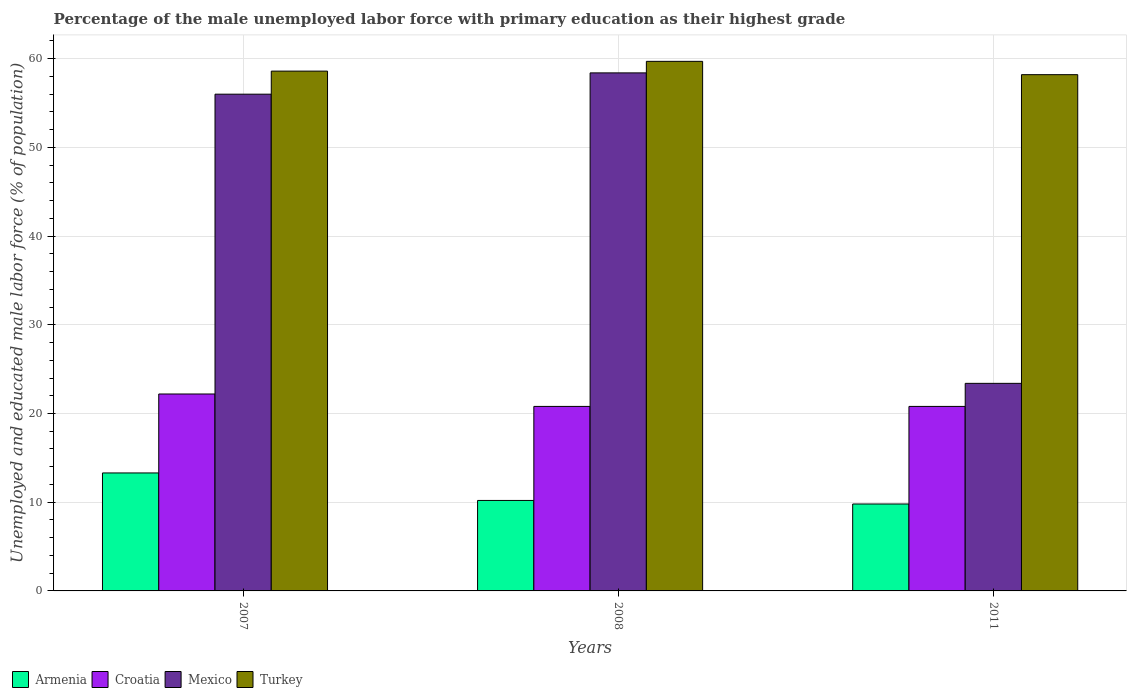How many different coloured bars are there?
Provide a succinct answer. 4. Are the number of bars per tick equal to the number of legend labels?
Give a very brief answer. Yes. Are the number of bars on each tick of the X-axis equal?
Your answer should be very brief. Yes. How many bars are there on the 2nd tick from the left?
Your answer should be very brief. 4. How many bars are there on the 2nd tick from the right?
Offer a very short reply. 4. What is the label of the 3rd group of bars from the left?
Offer a very short reply. 2011. What is the percentage of the unemployed male labor force with primary education in Turkey in 2011?
Your answer should be compact. 58.2. Across all years, what is the maximum percentage of the unemployed male labor force with primary education in Croatia?
Your response must be concise. 22.2. Across all years, what is the minimum percentage of the unemployed male labor force with primary education in Turkey?
Your answer should be very brief. 58.2. What is the total percentage of the unemployed male labor force with primary education in Turkey in the graph?
Offer a very short reply. 176.5. What is the difference between the percentage of the unemployed male labor force with primary education in Mexico in 2007 and that in 2011?
Offer a terse response. 32.6. What is the difference between the percentage of the unemployed male labor force with primary education in Mexico in 2008 and the percentage of the unemployed male labor force with primary education in Turkey in 2011?
Your answer should be compact. 0.2. What is the average percentage of the unemployed male labor force with primary education in Mexico per year?
Offer a terse response. 45.93. In the year 2008, what is the difference between the percentage of the unemployed male labor force with primary education in Turkey and percentage of the unemployed male labor force with primary education in Mexico?
Offer a terse response. 1.3. What is the ratio of the percentage of the unemployed male labor force with primary education in Turkey in 2007 to that in 2008?
Give a very brief answer. 0.98. Is the percentage of the unemployed male labor force with primary education in Armenia in 2008 less than that in 2011?
Give a very brief answer. No. Is the difference between the percentage of the unemployed male labor force with primary education in Turkey in 2008 and 2011 greater than the difference between the percentage of the unemployed male labor force with primary education in Mexico in 2008 and 2011?
Ensure brevity in your answer.  No. What is the difference between the highest and the second highest percentage of the unemployed male labor force with primary education in Croatia?
Keep it short and to the point. 1.4. What is the difference between the highest and the lowest percentage of the unemployed male labor force with primary education in Mexico?
Keep it short and to the point. 35. Is it the case that in every year, the sum of the percentage of the unemployed male labor force with primary education in Armenia and percentage of the unemployed male labor force with primary education in Croatia is greater than the sum of percentage of the unemployed male labor force with primary education in Turkey and percentage of the unemployed male labor force with primary education in Mexico?
Provide a short and direct response. No. What does the 2nd bar from the left in 2011 represents?
Provide a succinct answer. Croatia. What does the 3rd bar from the right in 2008 represents?
Offer a terse response. Croatia. How many bars are there?
Ensure brevity in your answer.  12. Are all the bars in the graph horizontal?
Give a very brief answer. No. How many years are there in the graph?
Your response must be concise. 3. Does the graph contain grids?
Provide a short and direct response. Yes. Where does the legend appear in the graph?
Ensure brevity in your answer.  Bottom left. How are the legend labels stacked?
Your response must be concise. Horizontal. What is the title of the graph?
Your answer should be very brief. Percentage of the male unemployed labor force with primary education as their highest grade. Does "Iceland" appear as one of the legend labels in the graph?
Provide a short and direct response. No. What is the label or title of the X-axis?
Your answer should be compact. Years. What is the label or title of the Y-axis?
Offer a terse response. Unemployed and educated male labor force (% of population). What is the Unemployed and educated male labor force (% of population) of Armenia in 2007?
Your answer should be compact. 13.3. What is the Unemployed and educated male labor force (% of population) of Croatia in 2007?
Ensure brevity in your answer.  22.2. What is the Unemployed and educated male labor force (% of population) of Mexico in 2007?
Your answer should be very brief. 56. What is the Unemployed and educated male labor force (% of population) of Turkey in 2007?
Ensure brevity in your answer.  58.6. What is the Unemployed and educated male labor force (% of population) of Armenia in 2008?
Offer a very short reply. 10.2. What is the Unemployed and educated male labor force (% of population) of Croatia in 2008?
Your response must be concise. 20.8. What is the Unemployed and educated male labor force (% of population) in Mexico in 2008?
Ensure brevity in your answer.  58.4. What is the Unemployed and educated male labor force (% of population) of Turkey in 2008?
Ensure brevity in your answer.  59.7. What is the Unemployed and educated male labor force (% of population) of Armenia in 2011?
Give a very brief answer. 9.8. What is the Unemployed and educated male labor force (% of population) of Croatia in 2011?
Give a very brief answer. 20.8. What is the Unemployed and educated male labor force (% of population) in Mexico in 2011?
Your answer should be very brief. 23.4. What is the Unemployed and educated male labor force (% of population) of Turkey in 2011?
Offer a very short reply. 58.2. Across all years, what is the maximum Unemployed and educated male labor force (% of population) of Armenia?
Give a very brief answer. 13.3. Across all years, what is the maximum Unemployed and educated male labor force (% of population) of Croatia?
Offer a terse response. 22.2. Across all years, what is the maximum Unemployed and educated male labor force (% of population) in Mexico?
Your response must be concise. 58.4. Across all years, what is the maximum Unemployed and educated male labor force (% of population) of Turkey?
Provide a succinct answer. 59.7. Across all years, what is the minimum Unemployed and educated male labor force (% of population) of Armenia?
Your response must be concise. 9.8. Across all years, what is the minimum Unemployed and educated male labor force (% of population) of Croatia?
Keep it short and to the point. 20.8. Across all years, what is the minimum Unemployed and educated male labor force (% of population) of Mexico?
Give a very brief answer. 23.4. Across all years, what is the minimum Unemployed and educated male labor force (% of population) of Turkey?
Your answer should be compact. 58.2. What is the total Unemployed and educated male labor force (% of population) of Armenia in the graph?
Make the answer very short. 33.3. What is the total Unemployed and educated male labor force (% of population) in Croatia in the graph?
Offer a terse response. 63.8. What is the total Unemployed and educated male labor force (% of population) in Mexico in the graph?
Offer a very short reply. 137.8. What is the total Unemployed and educated male labor force (% of population) in Turkey in the graph?
Provide a short and direct response. 176.5. What is the difference between the Unemployed and educated male labor force (% of population) in Armenia in 2007 and that in 2011?
Your response must be concise. 3.5. What is the difference between the Unemployed and educated male labor force (% of population) of Croatia in 2007 and that in 2011?
Give a very brief answer. 1.4. What is the difference between the Unemployed and educated male labor force (% of population) in Mexico in 2007 and that in 2011?
Your response must be concise. 32.6. What is the difference between the Unemployed and educated male labor force (% of population) of Turkey in 2007 and that in 2011?
Your answer should be very brief. 0.4. What is the difference between the Unemployed and educated male labor force (% of population) of Croatia in 2008 and that in 2011?
Provide a succinct answer. 0. What is the difference between the Unemployed and educated male labor force (% of population) in Armenia in 2007 and the Unemployed and educated male labor force (% of population) in Mexico in 2008?
Ensure brevity in your answer.  -45.1. What is the difference between the Unemployed and educated male labor force (% of population) in Armenia in 2007 and the Unemployed and educated male labor force (% of population) in Turkey in 2008?
Give a very brief answer. -46.4. What is the difference between the Unemployed and educated male labor force (% of population) in Croatia in 2007 and the Unemployed and educated male labor force (% of population) in Mexico in 2008?
Make the answer very short. -36.2. What is the difference between the Unemployed and educated male labor force (% of population) in Croatia in 2007 and the Unemployed and educated male labor force (% of population) in Turkey in 2008?
Offer a very short reply. -37.5. What is the difference between the Unemployed and educated male labor force (% of population) of Armenia in 2007 and the Unemployed and educated male labor force (% of population) of Mexico in 2011?
Provide a short and direct response. -10.1. What is the difference between the Unemployed and educated male labor force (% of population) of Armenia in 2007 and the Unemployed and educated male labor force (% of population) of Turkey in 2011?
Make the answer very short. -44.9. What is the difference between the Unemployed and educated male labor force (% of population) in Croatia in 2007 and the Unemployed and educated male labor force (% of population) in Mexico in 2011?
Ensure brevity in your answer.  -1.2. What is the difference between the Unemployed and educated male labor force (% of population) of Croatia in 2007 and the Unemployed and educated male labor force (% of population) of Turkey in 2011?
Ensure brevity in your answer.  -36. What is the difference between the Unemployed and educated male labor force (% of population) of Mexico in 2007 and the Unemployed and educated male labor force (% of population) of Turkey in 2011?
Give a very brief answer. -2.2. What is the difference between the Unemployed and educated male labor force (% of population) of Armenia in 2008 and the Unemployed and educated male labor force (% of population) of Croatia in 2011?
Your answer should be compact. -10.6. What is the difference between the Unemployed and educated male labor force (% of population) in Armenia in 2008 and the Unemployed and educated male labor force (% of population) in Turkey in 2011?
Ensure brevity in your answer.  -48. What is the difference between the Unemployed and educated male labor force (% of population) of Croatia in 2008 and the Unemployed and educated male labor force (% of population) of Turkey in 2011?
Give a very brief answer. -37.4. What is the difference between the Unemployed and educated male labor force (% of population) in Mexico in 2008 and the Unemployed and educated male labor force (% of population) in Turkey in 2011?
Offer a terse response. 0.2. What is the average Unemployed and educated male labor force (% of population) of Armenia per year?
Your answer should be compact. 11.1. What is the average Unemployed and educated male labor force (% of population) in Croatia per year?
Give a very brief answer. 21.27. What is the average Unemployed and educated male labor force (% of population) in Mexico per year?
Make the answer very short. 45.93. What is the average Unemployed and educated male labor force (% of population) of Turkey per year?
Ensure brevity in your answer.  58.83. In the year 2007, what is the difference between the Unemployed and educated male labor force (% of population) of Armenia and Unemployed and educated male labor force (% of population) of Croatia?
Your answer should be compact. -8.9. In the year 2007, what is the difference between the Unemployed and educated male labor force (% of population) in Armenia and Unemployed and educated male labor force (% of population) in Mexico?
Your answer should be very brief. -42.7. In the year 2007, what is the difference between the Unemployed and educated male labor force (% of population) in Armenia and Unemployed and educated male labor force (% of population) in Turkey?
Offer a terse response. -45.3. In the year 2007, what is the difference between the Unemployed and educated male labor force (% of population) of Croatia and Unemployed and educated male labor force (% of population) of Mexico?
Offer a terse response. -33.8. In the year 2007, what is the difference between the Unemployed and educated male labor force (% of population) in Croatia and Unemployed and educated male labor force (% of population) in Turkey?
Offer a terse response. -36.4. In the year 2008, what is the difference between the Unemployed and educated male labor force (% of population) in Armenia and Unemployed and educated male labor force (% of population) in Mexico?
Ensure brevity in your answer.  -48.2. In the year 2008, what is the difference between the Unemployed and educated male labor force (% of population) of Armenia and Unemployed and educated male labor force (% of population) of Turkey?
Your answer should be very brief. -49.5. In the year 2008, what is the difference between the Unemployed and educated male labor force (% of population) of Croatia and Unemployed and educated male labor force (% of population) of Mexico?
Ensure brevity in your answer.  -37.6. In the year 2008, what is the difference between the Unemployed and educated male labor force (% of population) of Croatia and Unemployed and educated male labor force (% of population) of Turkey?
Make the answer very short. -38.9. In the year 2011, what is the difference between the Unemployed and educated male labor force (% of population) in Armenia and Unemployed and educated male labor force (% of population) in Croatia?
Keep it short and to the point. -11. In the year 2011, what is the difference between the Unemployed and educated male labor force (% of population) in Armenia and Unemployed and educated male labor force (% of population) in Turkey?
Provide a succinct answer. -48.4. In the year 2011, what is the difference between the Unemployed and educated male labor force (% of population) in Croatia and Unemployed and educated male labor force (% of population) in Mexico?
Provide a succinct answer. -2.6. In the year 2011, what is the difference between the Unemployed and educated male labor force (% of population) of Croatia and Unemployed and educated male labor force (% of population) of Turkey?
Keep it short and to the point. -37.4. In the year 2011, what is the difference between the Unemployed and educated male labor force (% of population) in Mexico and Unemployed and educated male labor force (% of population) in Turkey?
Make the answer very short. -34.8. What is the ratio of the Unemployed and educated male labor force (% of population) of Armenia in 2007 to that in 2008?
Offer a terse response. 1.3. What is the ratio of the Unemployed and educated male labor force (% of population) in Croatia in 2007 to that in 2008?
Give a very brief answer. 1.07. What is the ratio of the Unemployed and educated male labor force (% of population) of Mexico in 2007 to that in 2008?
Your response must be concise. 0.96. What is the ratio of the Unemployed and educated male labor force (% of population) in Turkey in 2007 to that in 2008?
Your answer should be very brief. 0.98. What is the ratio of the Unemployed and educated male labor force (% of population) of Armenia in 2007 to that in 2011?
Provide a succinct answer. 1.36. What is the ratio of the Unemployed and educated male labor force (% of population) in Croatia in 2007 to that in 2011?
Give a very brief answer. 1.07. What is the ratio of the Unemployed and educated male labor force (% of population) in Mexico in 2007 to that in 2011?
Offer a terse response. 2.39. What is the ratio of the Unemployed and educated male labor force (% of population) of Turkey in 2007 to that in 2011?
Keep it short and to the point. 1.01. What is the ratio of the Unemployed and educated male labor force (% of population) in Armenia in 2008 to that in 2011?
Your answer should be compact. 1.04. What is the ratio of the Unemployed and educated male labor force (% of population) of Mexico in 2008 to that in 2011?
Offer a very short reply. 2.5. What is the ratio of the Unemployed and educated male labor force (% of population) of Turkey in 2008 to that in 2011?
Offer a terse response. 1.03. What is the difference between the highest and the second highest Unemployed and educated male labor force (% of population) of Armenia?
Your answer should be compact. 3.1. What is the difference between the highest and the second highest Unemployed and educated male labor force (% of population) in Turkey?
Offer a terse response. 1.1. What is the difference between the highest and the lowest Unemployed and educated male labor force (% of population) in Turkey?
Make the answer very short. 1.5. 